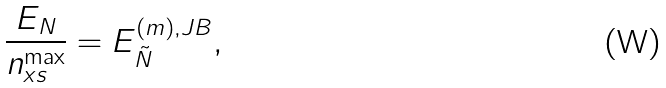<formula> <loc_0><loc_0><loc_500><loc_500>\frac { E _ { N } } { n _ { x s } ^ { \max } } = E _ { \tilde { N } } ^ { ( m ) , J B } ,</formula> 